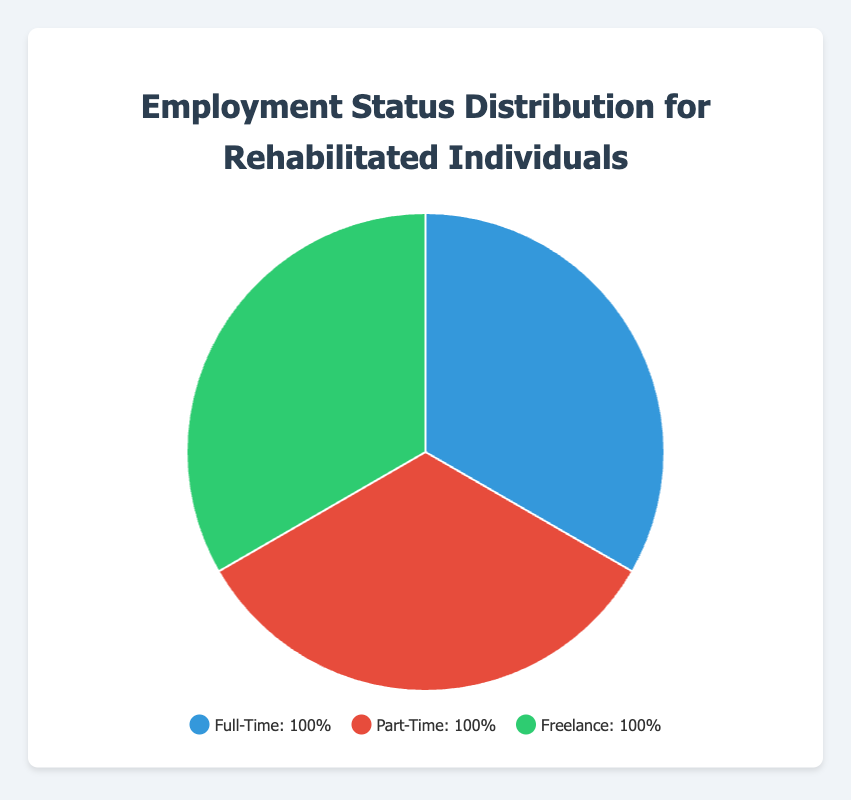What is the most common employment status among rehabilitated individuals? By looking at the pie chart, the segment with the largest area represents the most common employment status. It is frequently highlighted in charts to draw attention to significant data points.
Answer: Full-Time Which employment status has the smallest percentage representation in the chart? Identify the smallest segment in the pie chart by comparing the proportions of each section. The smallest segment represents the least common employment status.
Answer: Freelance What is the percentage point difference between Full-Time and Part-Time employment? Subtract the percentage of Part-Time employment from the percentage of Full-Time employment. Full-Time is 100%, Part-Time is 100%, so the difference is 45% - 40%.
Answer: 5% How much more prevalent is the Full-Time employment status compared to the Freelance employment status? Compare the percentages of Full-Time and Freelance employment statuses by subtracting the Freelance percentage from the Full-Time percentage. The Full-Time segment is 100%, and Freelance is 100%.
Answer: 15% What is the total percentage of rehabilitated individuals who are either Full-Time or Freelance employed? Add the percentages of Full-Time employment and Freelance employment to get the combined total. Here, the total is 45% (Full-Time) + 25% (Full-Time) + 30% (Full-Time) + 50% (Freelance) = 45% + 30% + 25% + 50%.
Answer: 100% What is the average percentage of the three employment statuses? To find the average percentage, sum the percentages of all three employment statuses and then divide by the number of statuses. The sum is 100%, and there are 3 statuses, so the average is 100/3.
Answer: 33.33% Which employment status is represented by the red color in the chart? Look at the color legend provided in the chart to match the color with the corresponding employment status.
Answer: Full-Time Between Part-Time and Freelance, which employment status shows a wider representation visually, and by how much? Compare the sizes of the Part-Time and Freelance segments in the pie chart. Visually measure the difference in their representations by comparing their proportions.
Answer: Part-Time, by 5% 